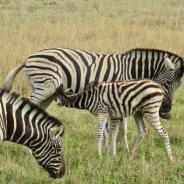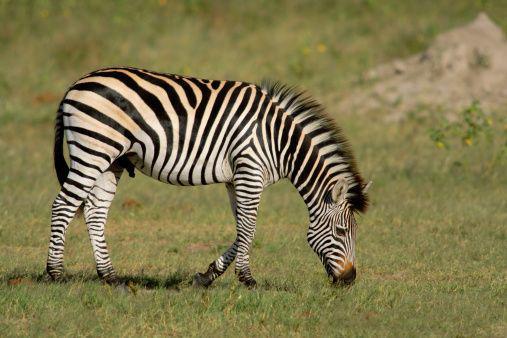The first image is the image on the left, the second image is the image on the right. Assess this claim about the two images: "A baby zebra is shown nursing in one image.". Correct or not? Answer yes or no. Yes. The first image is the image on the left, the second image is the image on the right. Evaluate the accuracy of this statement regarding the images: "There is a baby zebra eating from its mother zebra.". Is it true? Answer yes or no. Yes. 